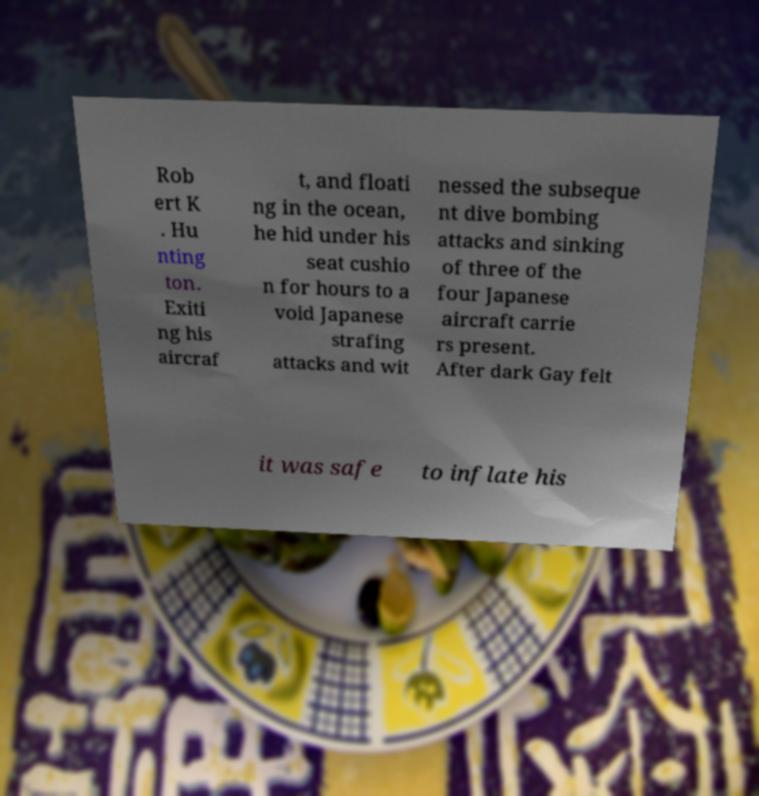Can you read and provide the text displayed in the image?This photo seems to have some interesting text. Can you extract and type it out for me? Rob ert K . Hu nting ton. Exiti ng his aircraf t, and floati ng in the ocean, he hid under his seat cushio n for hours to a void Japanese strafing attacks and wit nessed the subseque nt dive bombing attacks and sinking of three of the four Japanese aircraft carrie rs present. After dark Gay felt it was safe to inflate his 